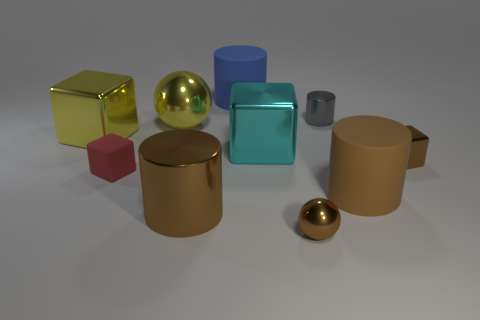What is the shape of the big shiny object that is the same color as the small sphere?
Provide a short and direct response. Cylinder. What size is the metal cube that is the same color as the small ball?
Your response must be concise. Small. What number of objects are big shiny things in front of the tiny red rubber object or things that are left of the tiny red rubber cube?
Keep it short and to the point. 2. How many matte objects are in front of the blue matte object and to the left of the cyan metal block?
Ensure brevity in your answer.  1. Is the tiny gray thing made of the same material as the yellow cube?
Your response must be concise. Yes. There is a large metallic thing behind the large shiny object that is to the left of the shiny ball behind the brown block; what is its shape?
Offer a very short reply. Sphere. What is the material of the cube that is both to the right of the big blue cylinder and on the left side of the tiny metal block?
Your answer should be very brief. Metal. The large metal object to the right of the large brown metallic cylinder on the left side of the brown matte cylinder on the right side of the brown metal sphere is what color?
Offer a very short reply. Cyan. What number of red objects are either small matte things or metal spheres?
Offer a terse response. 1. How many other things are there of the same size as the cyan shiny cube?
Offer a very short reply. 5. 